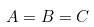Convert formula to latex. <formula><loc_0><loc_0><loc_500><loc_500>A = B = C</formula> 